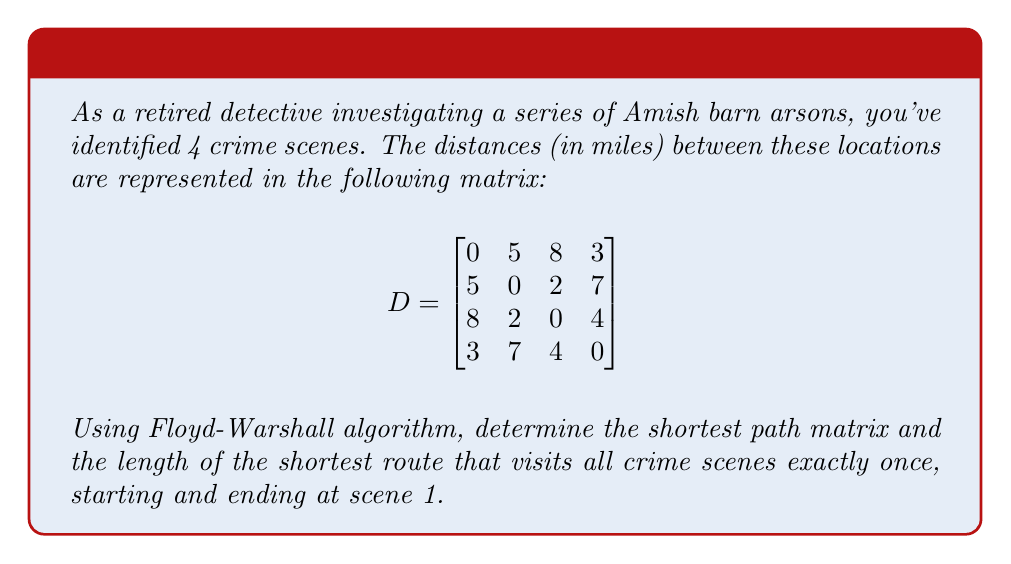Show me your answer to this math problem. 1. Apply the Floyd-Warshall algorithm to find the shortest path matrix:

   Initialize the matrix $P = D$

   For $k = 1$ to $4$:
     For $i = 1$ to $4$:
       For $j = 1$ to $4$:
         $P_{ij} = \min(P_{ij}, P_{ik} + P_{kj})$

   After all iterations, we get the shortest path matrix:

   $$
   P = \begin{bmatrix}
   0 & 5 & 7 & 3 \\
   5 & 0 & 2 & 6 \\
   7 & 2 & 0 & 4 \\
   3 & 6 & 4 & 0
   \end{bmatrix}
   $$

2. To find the shortest route visiting all scenes once:
   - Start at scene 1
   - Find the shortest path to an unvisited scene
   - Repeat until all scenes are visited
   - Return to scene 1

3. Possible routes:
   1 → 4 → 3 → 2 → 1: 3 + 4 + 2 + 5 = 14 miles
   1 → 2 → 3 → 4 → 1: 5 + 2 + 4 + 3 = 14 miles

Both routes have the same shortest distance of 14 miles.
Answer: 14 miles 